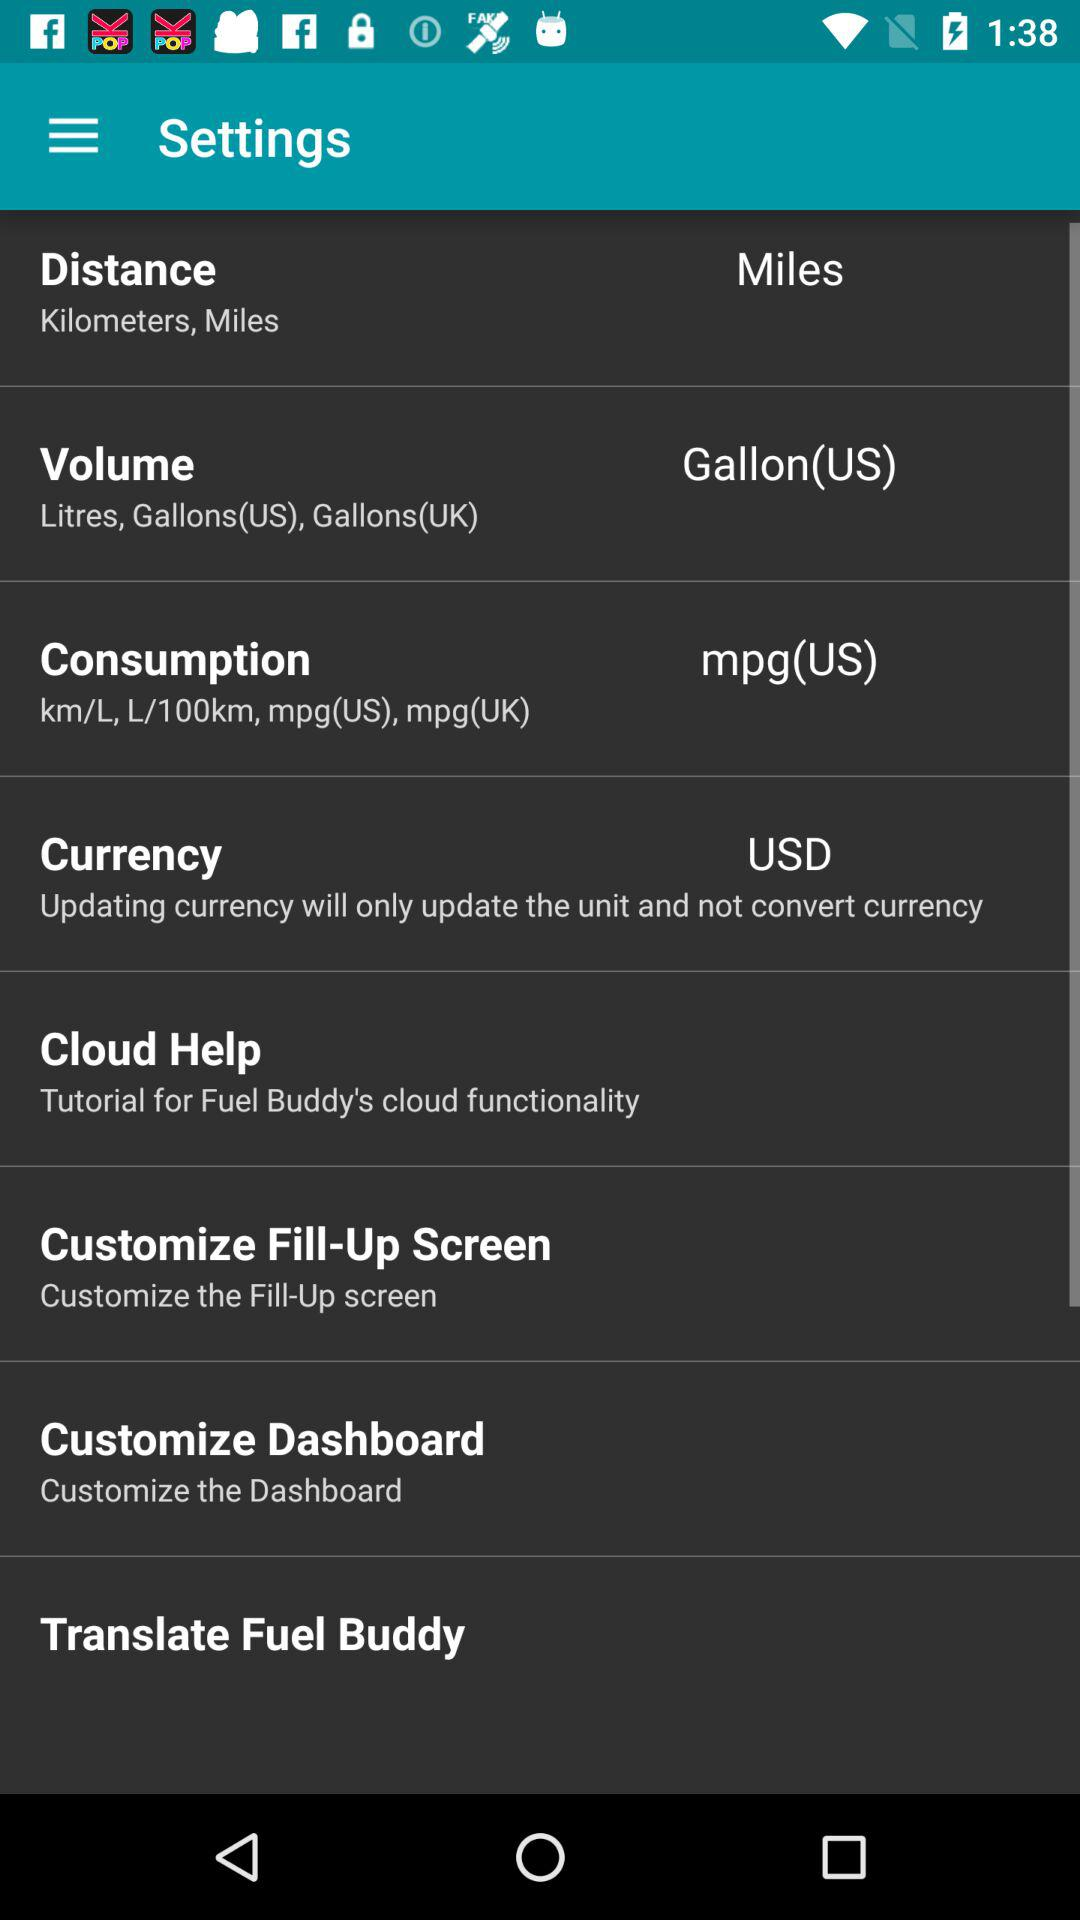What's the selected unit of volume? The selected unit of volume is the gallon (US). 